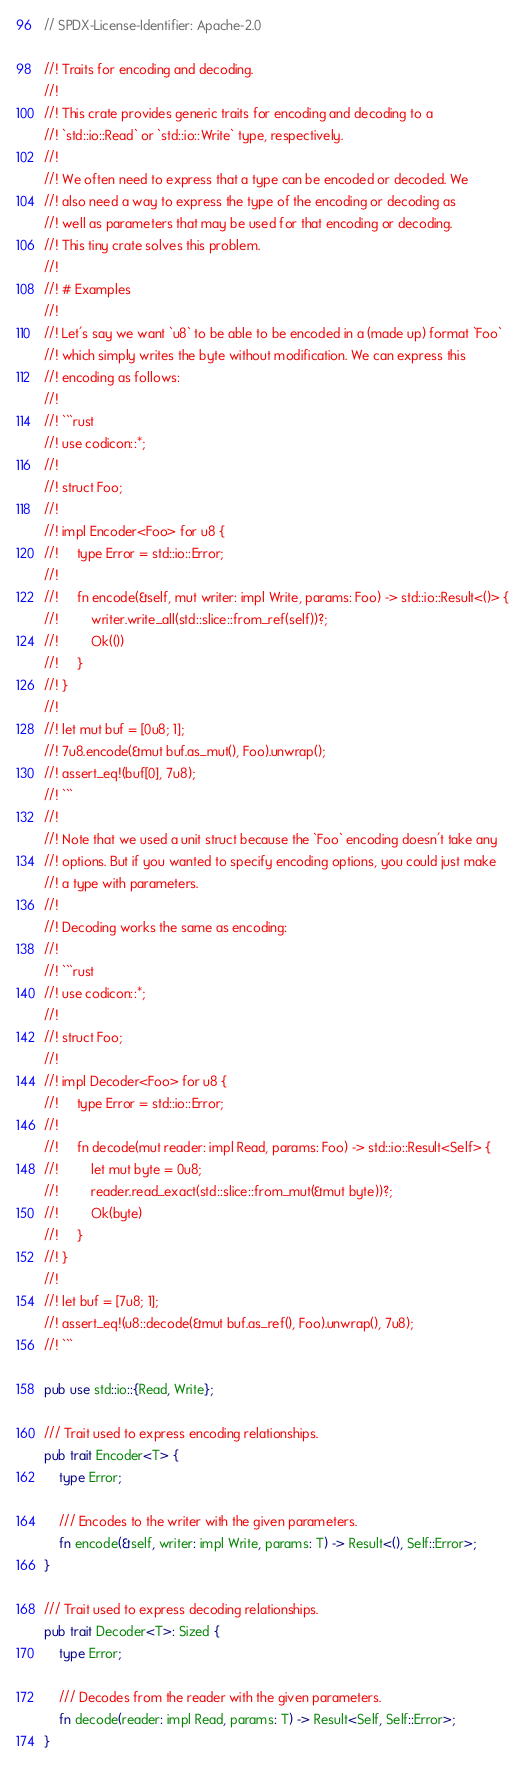Convert code to text. <code><loc_0><loc_0><loc_500><loc_500><_Rust_>// SPDX-License-Identifier: Apache-2.0

//! Traits for encoding and decoding.
//!
//! This crate provides generic traits for encoding and decoding to a
//! `std::io::Read` or `std::io::Write` type, respectively.
//!
//! We often need to express that a type can be encoded or decoded. We
//! also need a way to express the type of the encoding or decoding as
//! well as parameters that may be used for that encoding or decoding.
//! This tiny crate solves this problem.
//!
//! # Examples
//!
//! Let's say we want `u8` to be able to be encoded in a (made up) format `Foo`
//! which simply writes the byte without modification. We can express this
//! encoding as follows:
//!
//! ```rust
//! use codicon::*;
//!
//! struct Foo;
//!
//! impl Encoder<Foo> for u8 {
//!     type Error = std::io::Error;
//!
//!     fn encode(&self, mut writer: impl Write, params: Foo) -> std::io::Result<()> {
//!         writer.write_all(std::slice::from_ref(self))?;
//!         Ok(())
//!     }
//! }
//!
//! let mut buf = [0u8; 1];
//! 7u8.encode(&mut buf.as_mut(), Foo).unwrap();
//! assert_eq!(buf[0], 7u8);
//! ```
//!
//! Note that we used a unit struct because the `Foo` encoding doesn't take any
//! options. But if you wanted to specify encoding options, you could just make
//! a type with parameters.
//!
//! Decoding works the same as encoding:
//!
//! ```rust
//! use codicon::*;
//!
//! struct Foo;
//!
//! impl Decoder<Foo> for u8 {
//!     type Error = std::io::Error;
//!
//!     fn decode(mut reader: impl Read, params: Foo) -> std::io::Result<Self> {
//!         let mut byte = 0u8;
//!         reader.read_exact(std::slice::from_mut(&mut byte))?;
//!         Ok(byte)
//!     }
//! }
//!
//! let buf = [7u8; 1];
//! assert_eq!(u8::decode(&mut buf.as_ref(), Foo).unwrap(), 7u8);
//! ```

pub use std::io::{Read, Write};

/// Trait used to express encoding relationships.
pub trait Encoder<T> {
    type Error;

    /// Encodes to the writer with the given parameters.
    fn encode(&self, writer: impl Write, params: T) -> Result<(), Self::Error>;
}

/// Trait used to express decoding relationships.
pub trait Decoder<T>: Sized {
    type Error;

    /// Decodes from the reader with the given parameters.
    fn decode(reader: impl Read, params: T) -> Result<Self, Self::Error>;
}
</code> 